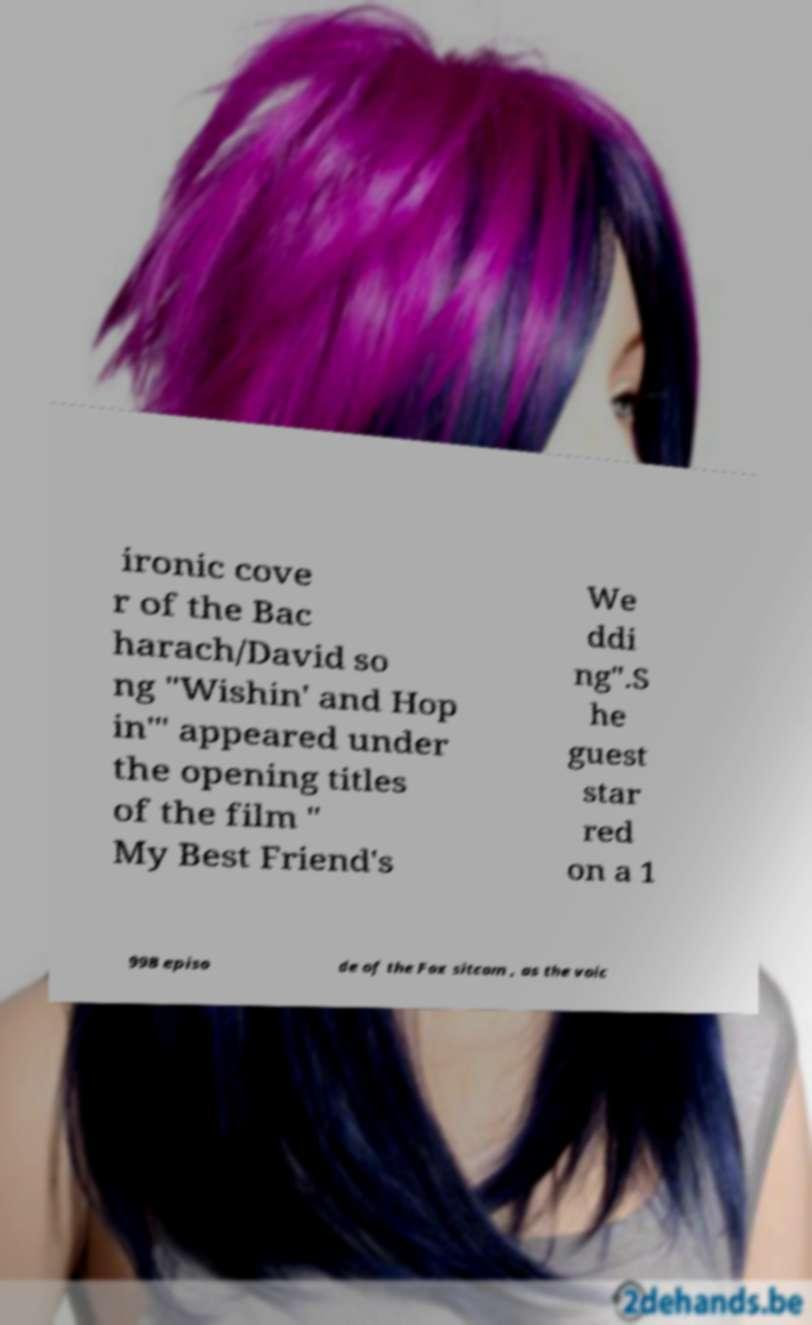Could you assist in decoding the text presented in this image and type it out clearly? ironic cove r of the Bac harach/David so ng "Wishin' and Hop in'" appeared under the opening titles of the film " My Best Friend's We ddi ng".S he guest star red on a 1 998 episo de of the Fox sitcom , as the voic 